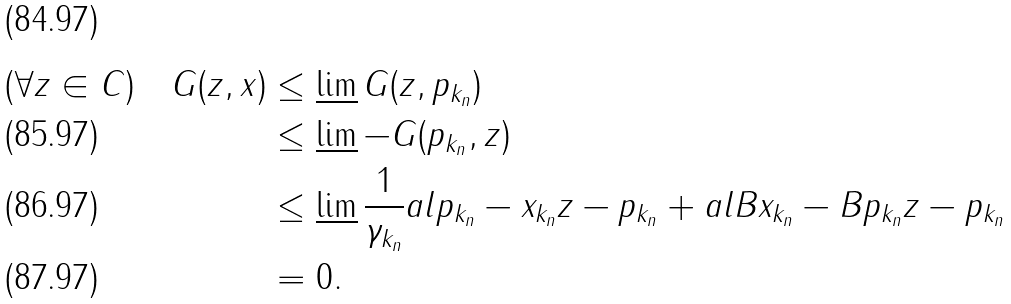Convert formula to latex. <formula><loc_0><loc_0><loc_500><loc_500>( \forall z \in C ) \quad G ( z , x ) & \leq \varliminf G ( z , p _ { k _ { n } } ) \\ & \leq \varliminf - G ( p _ { k _ { n } } , z ) \\ & \leq \varliminf \frac { 1 } { \gamma _ { k _ { n } } } a l { p _ { k _ { n } } - x _ { k _ { n } } } { z - p _ { k _ { n } } } + a l { B x _ { k _ { n } } - B p _ { k _ { n } } } { z - p _ { k _ { n } } } \\ & = 0 .</formula> 